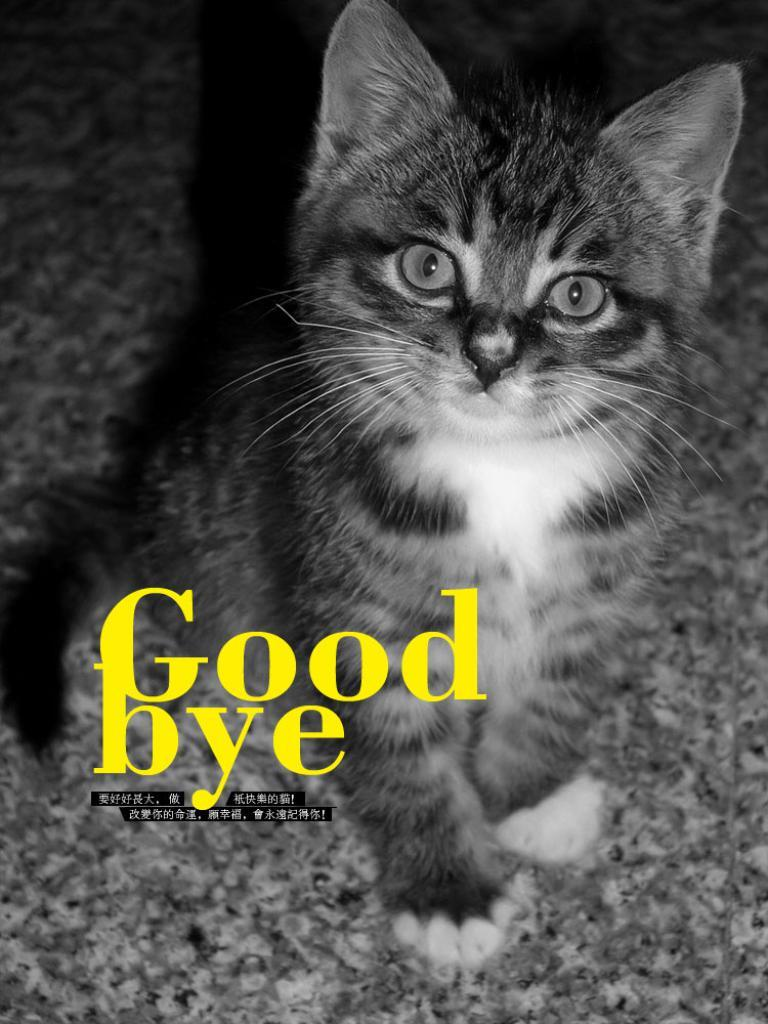What type of animal is in the image? There is a cat in the image. Where is the cat located in the image? The cat is sitting on the floor. What else can be seen in the image besides the cat? There is some text in the image. What type of ear is the cat wearing in the image? The cat is not wearing an ear in the image. Is there a battle taking place in the image? There is no battle depicted in the image. 